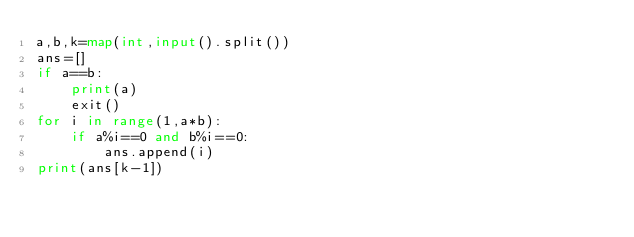<code> <loc_0><loc_0><loc_500><loc_500><_Python_>a,b,k=map(int,input().split())
ans=[]
if a==b:
    print(a)
    exit()
for i in range(1,a*b):
    if a%i==0 and b%i==0:
        ans.append(i)
print(ans[k-1])
</code> 